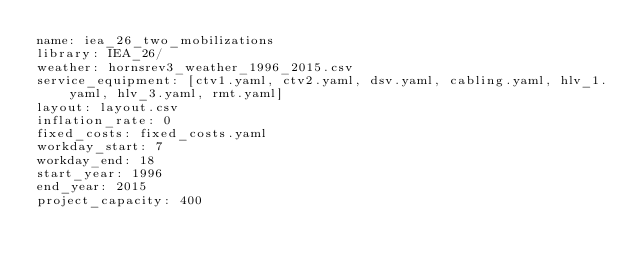Convert code to text. <code><loc_0><loc_0><loc_500><loc_500><_YAML_>name: iea_26_two_mobilizations
library: IEA_26/
weather: hornsrev3_weather_1996_2015.csv
service_equipment: [ctv1.yaml, ctv2.yaml, dsv.yaml, cabling.yaml, hlv_1.yaml, hlv_3.yaml, rmt.yaml]
layout: layout.csv
inflation_rate: 0
fixed_costs: fixed_costs.yaml
workday_start: 7
workday_end: 18
start_year: 1996
end_year: 2015
project_capacity: 400
</code> 